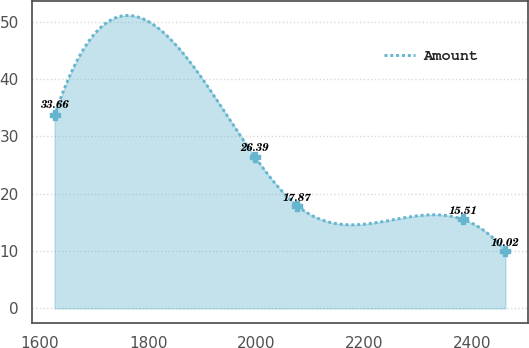Convert chart to OTSL. <chart><loc_0><loc_0><loc_500><loc_500><line_chart><ecel><fcel>Amount<nl><fcel>1627.07<fcel>33.66<nl><fcel>1997.81<fcel>26.39<nl><fcel>2076.15<fcel>17.87<nl><fcel>2382.34<fcel>15.51<nl><fcel>2460.68<fcel>10.02<nl></chart> 